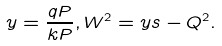<formula> <loc_0><loc_0><loc_500><loc_500>y = \frac { q P } { k P } , W ^ { 2 } = y s - Q ^ { 2 } .</formula> 